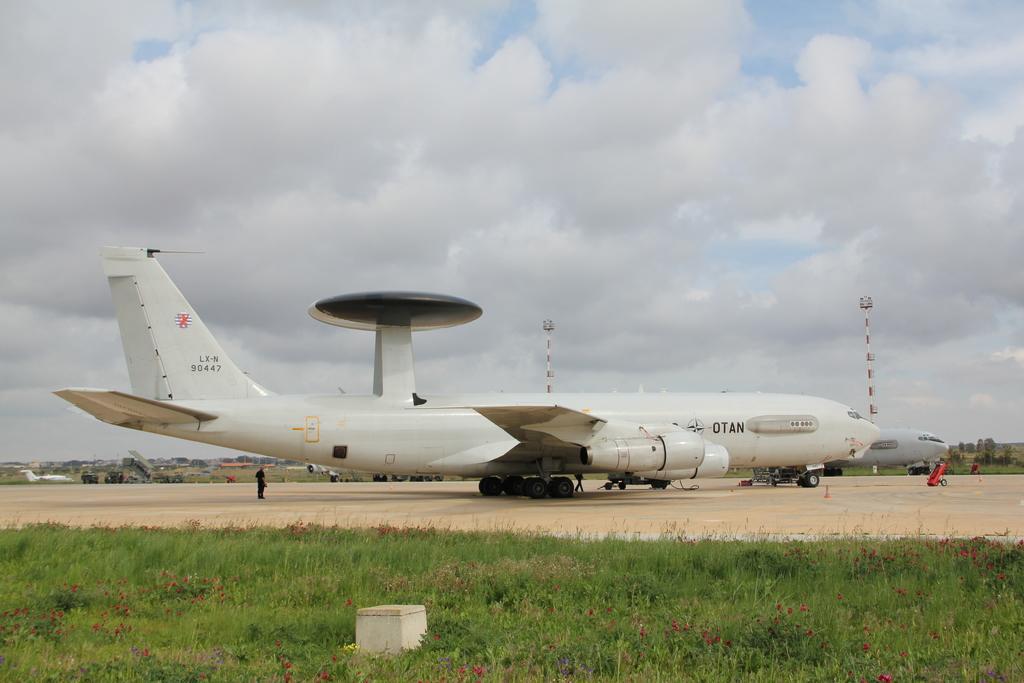In one or two sentences, can you explain what this image depicts? In this image we can see aeroplanes on the ground, and there is a grassy land at the bottom of this image, and there is a cloudy sky at the top of this image. 